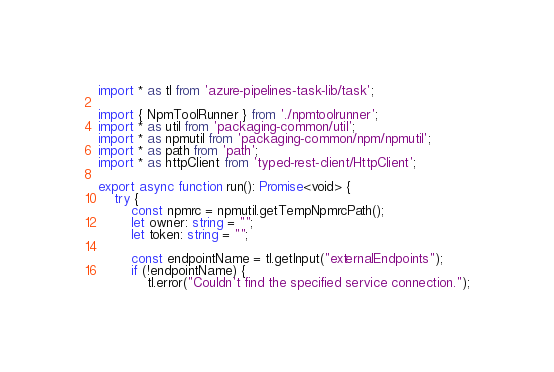<code> <loc_0><loc_0><loc_500><loc_500><_TypeScript_>import * as tl from 'azure-pipelines-task-lib/task';

import { NpmToolRunner } from './npmtoolrunner';
import * as util from 'packaging-common/util';
import * as npmutil from 'packaging-common/npm/npmutil';
import * as path from 'path';
import * as httpClient from 'typed-rest-client/HttpClient';

export async function run(): Promise<void> {
    try {
        const npmrc = npmutil.getTempNpmrcPath();
        let owner: string = "";
        let token: string = "";

        const endpointName = tl.getInput("externalEndpoints");
        if (!endpointName) {
            tl.error("Couldn't find the specified service connection.");</code> 